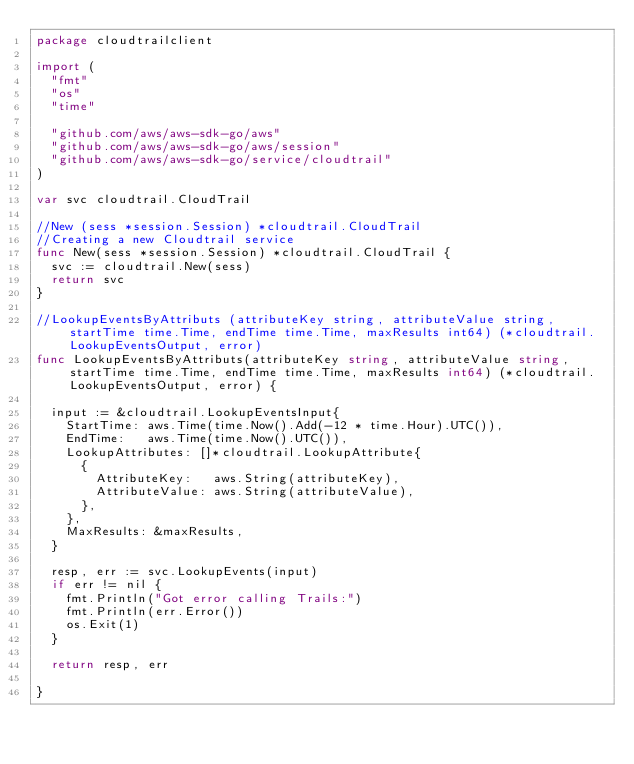<code> <loc_0><loc_0><loc_500><loc_500><_Go_>package cloudtrailclient

import (
	"fmt"
	"os"
	"time"

	"github.com/aws/aws-sdk-go/aws"
	"github.com/aws/aws-sdk-go/aws/session"
	"github.com/aws/aws-sdk-go/service/cloudtrail"
)

var svc cloudtrail.CloudTrail

//New (sess *session.Session) *cloudtrail.CloudTrail
//Creating a new Cloudtrail service
func New(sess *session.Session) *cloudtrail.CloudTrail {
	svc := cloudtrail.New(sess)
	return svc
}

//LookupEventsByAttributs (attributeKey string, attributeValue string, startTime time.Time, endTime time.Time, maxResults int64) (*cloudtrail.LookupEventsOutput, error)
func LookupEventsByAttributs(attributeKey string, attributeValue string, startTime time.Time, endTime time.Time, maxResults int64) (*cloudtrail.LookupEventsOutput, error) {

	input := &cloudtrail.LookupEventsInput{
		StartTime: aws.Time(time.Now().Add(-12 * time.Hour).UTC()),
		EndTime:   aws.Time(time.Now().UTC()),
		LookupAttributes: []*cloudtrail.LookupAttribute{
			{
				AttributeKey:   aws.String(attributeKey),
				AttributeValue: aws.String(attributeValue),
			},
		},
		MaxResults: &maxResults,
	}

	resp, err := svc.LookupEvents(input)
	if err != nil {
		fmt.Println("Got error calling Trails:")
		fmt.Println(err.Error())
		os.Exit(1)
	}

	return resp, err

}
</code> 